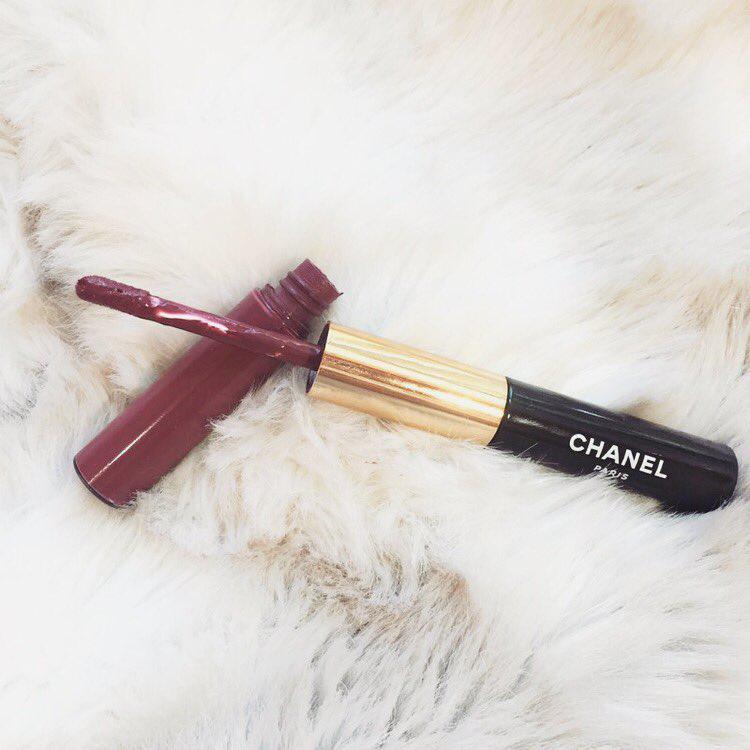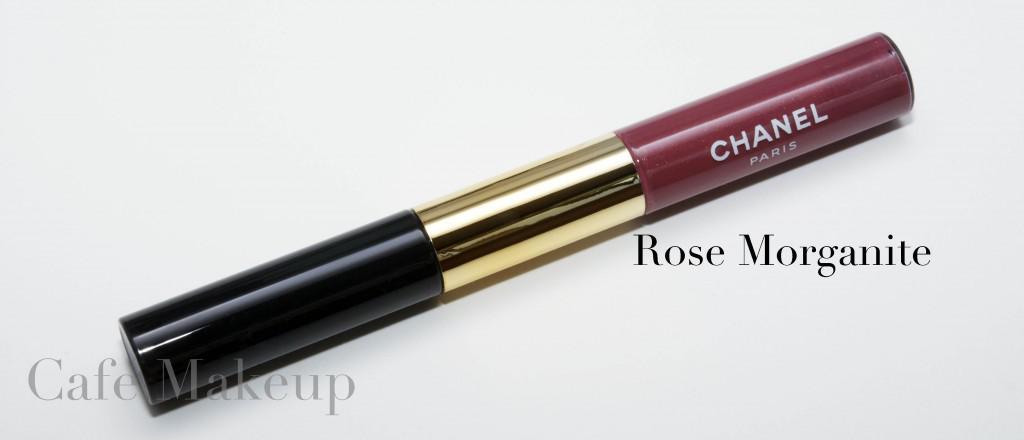The first image is the image on the left, the second image is the image on the right. Examine the images to the left and right. Is the description "There are two tubes of lipstick, and one of them is open while the other one is closed." accurate? Answer yes or no. Yes. The first image is the image on the left, the second image is the image on the right. Analyze the images presented: Is the assertion "Left image contains one lipstick with its applicator resting atop its base, and the right image shows one lipstick with its cap on." valid? Answer yes or no. Yes. 